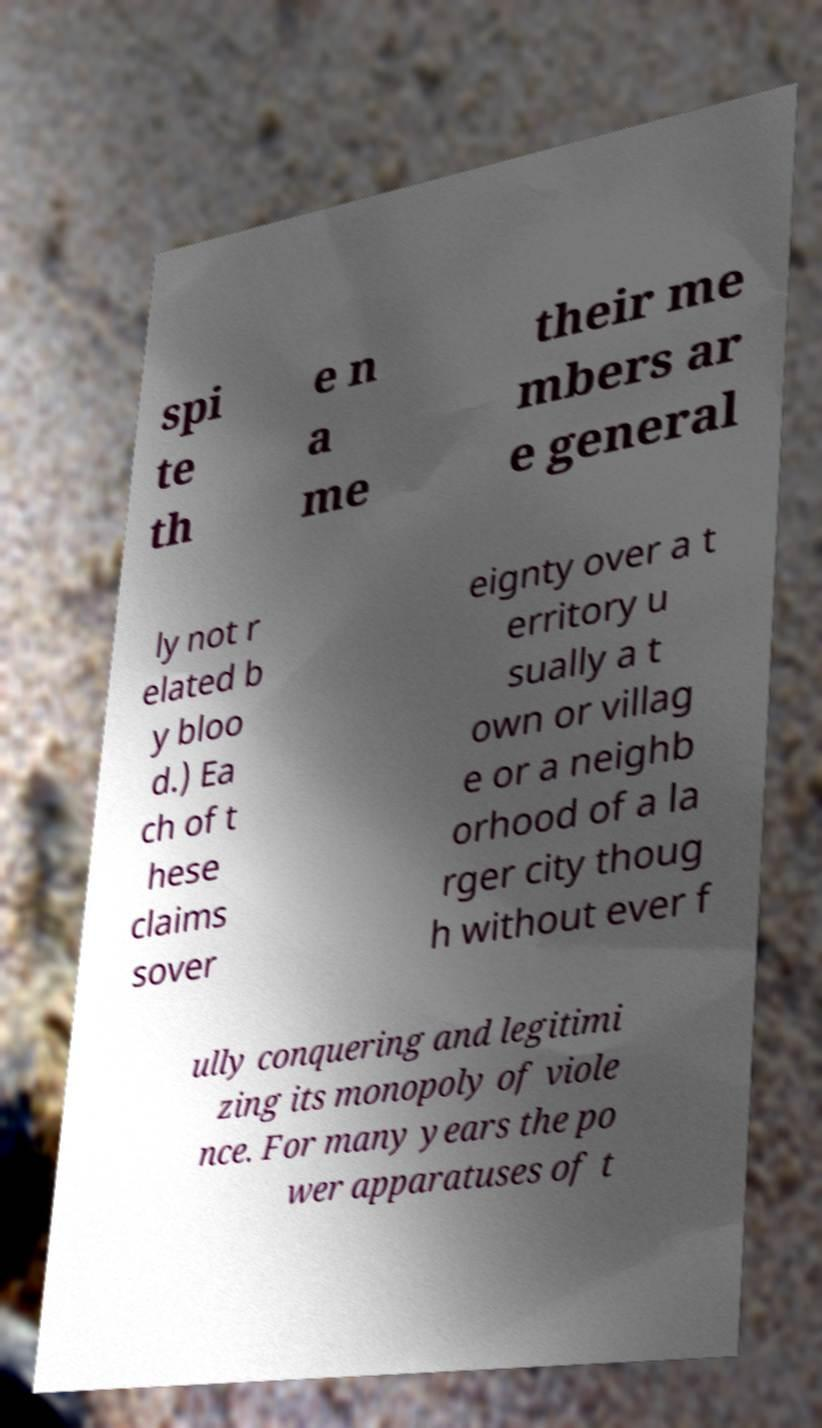Could you extract and type out the text from this image? spi te th e n a me their me mbers ar e general ly not r elated b y bloo d.) Ea ch of t hese claims sover eignty over a t erritory u sually a t own or villag e or a neighb orhood of a la rger city thoug h without ever f ully conquering and legitimi zing its monopoly of viole nce. For many years the po wer apparatuses of t 